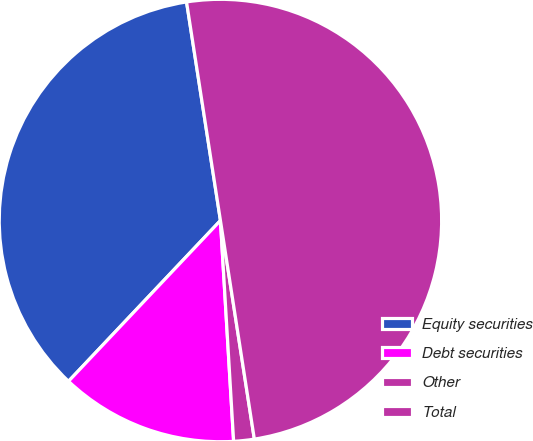Convert chart to OTSL. <chart><loc_0><loc_0><loc_500><loc_500><pie_chart><fcel>Equity securities<fcel>Debt securities<fcel>Other<fcel>Total<nl><fcel>35.5%<fcel>13.0%<fcel>1.5%<fcel>50.0%<nl></chart> 